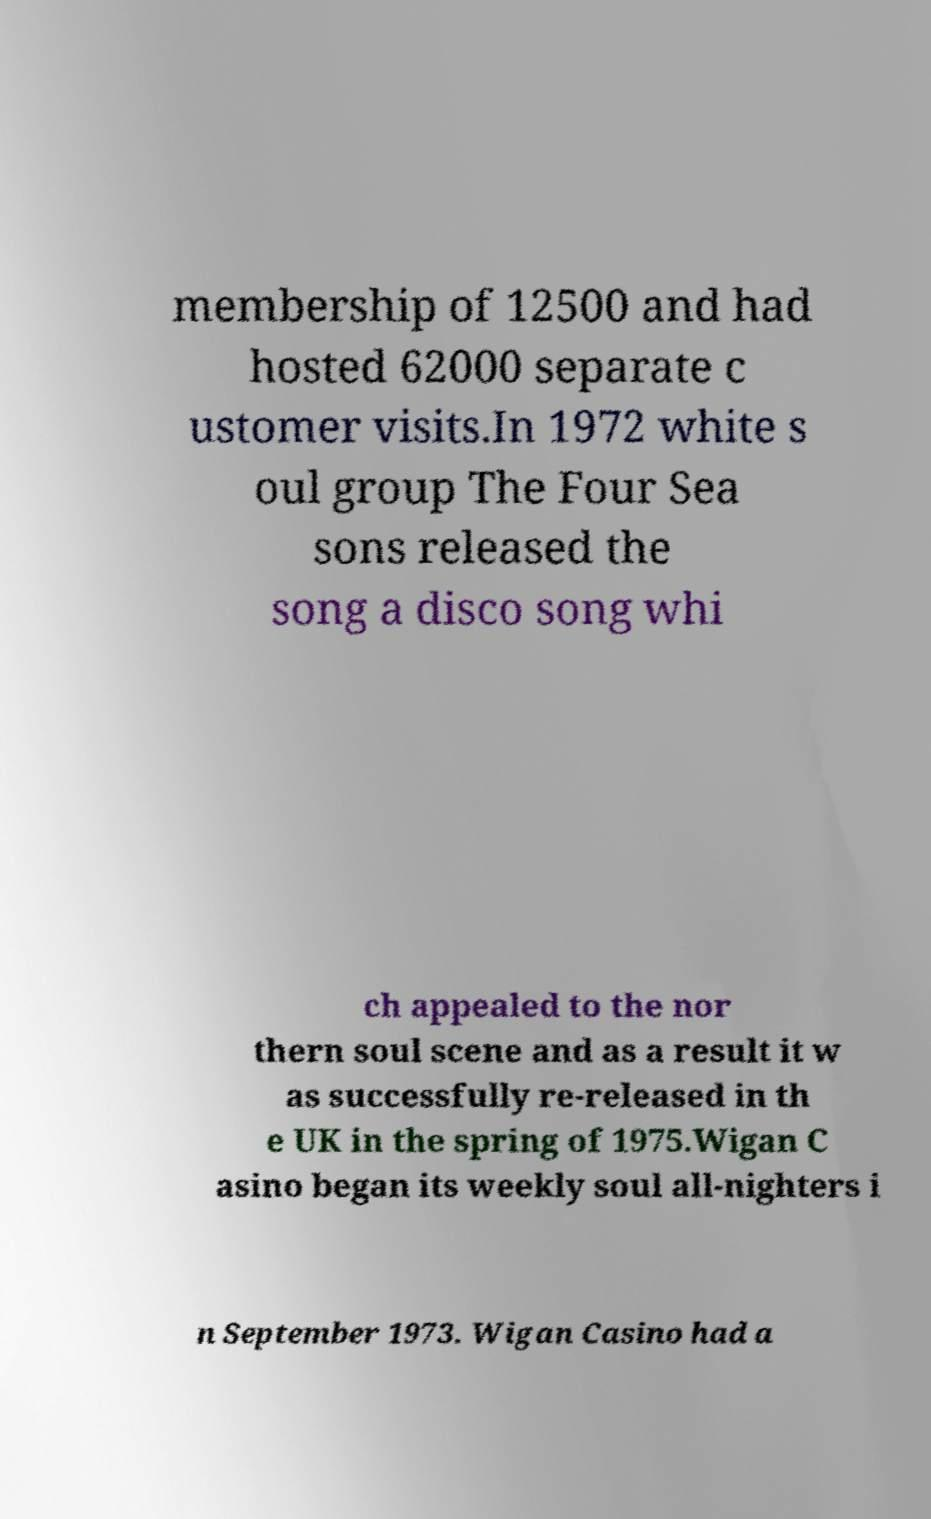Could you extract and type out the text from this image? membership of 12500 and had hosted 62000 separate c ustomer visits.In 1972 white s oul group The Four Sea sons released the song a disco song whi ch appealed to the nor thern soul scene and as a result it w as successfully re-released in th e UK in the spring of 1975.Wigan C asino began its weekly soul all-nighters i n September 1973. Wigan Casino had a 